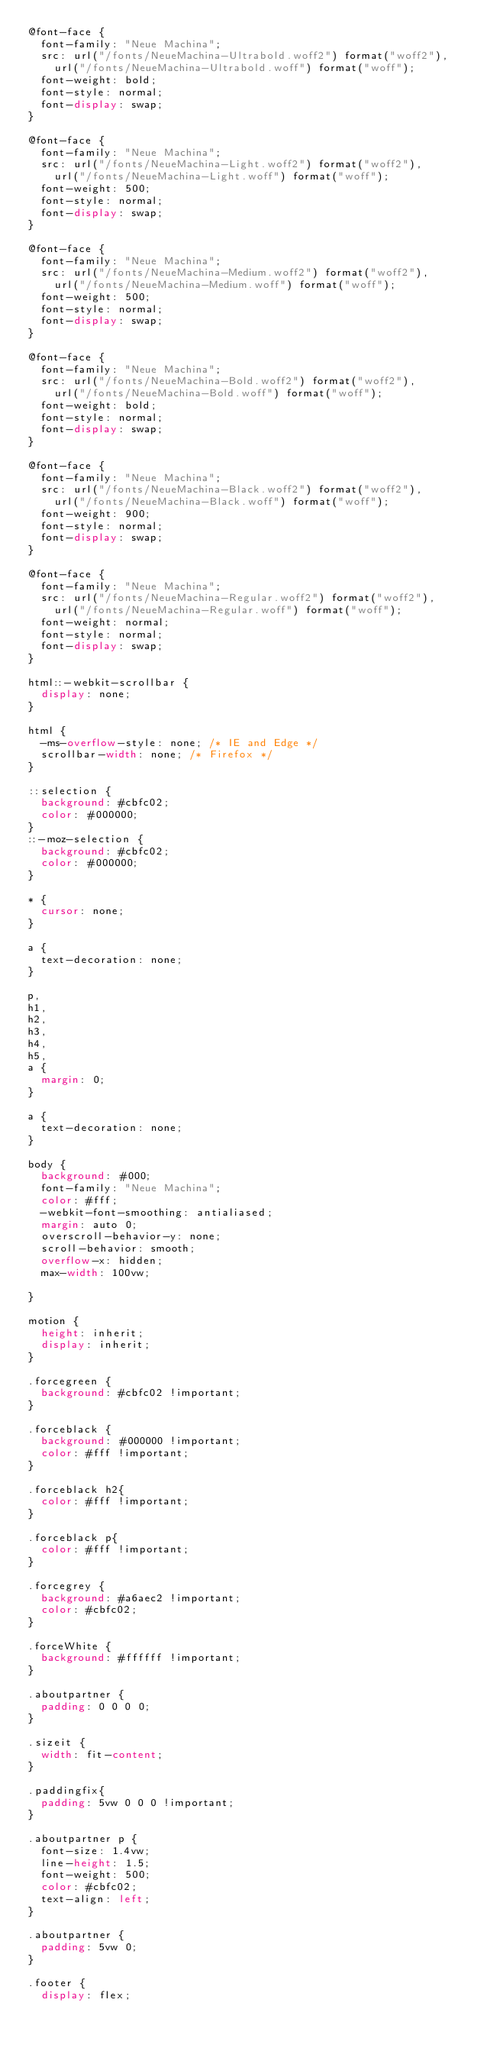Convert code to text. <code><loc_0><loc_0><loc_500><loc_500><_CSS_>@font-face {
  font-family: "Neue Machina";
  src: url("/fonts/NeueMachina-Ultrabold.woff2") format("woff2"),
    url("/fonts/NeueMachina-Ultrabold.woff") format("woff");
  font-weight: bold;
  font-style: normal;
  font-display: swap;
}

@font-face {
  font-family: "Neue Machina";
  src: url("/fonts/NeueMachina-Light.woff2") format("woff2"),
    url("/fonts/NeueMachina-Light.woff") format("woff");
  font-weight: 500;
  font-style: normal;
  font-display: swap;
}

@font-face {
  font-family: "Neue Machina";
  src: url("/fonts/NeueMachina-Medium.woff2") format("woff2"),
    url("/fonts/NeueMachina-Medium.woff") format("woff");
  font-weight: 500;
  font-style: normal;
  font-display: swap;
}

@font-face {
  font-family: "Neue Machina";
  src: url("/fonts/NeueMachina-Bold.woff2") format("woff2"),
    url("/fonts/NeueMachina-Bold.woff") format("woff");
  font-weight: bold;
  font-style: normal;
  font-display: swap;
}

@font-face {
  font-family: "Neue Machina";
  src: url("/fonts/NeueMachina-Black.woff2") format("woff2"),
    url("/fonts/NeueMachina-Black.woff") format("woff");
  font-weight: 900;
  font-style: normal;
  font-display: swap;
}

@font-face {
  font-family: "Neue Machina";
  src: url("/fonts/NeueMachina-Regular.woff2") format("woff2"),
    url("/fonts/NeueMachina-Regular.woff") format("woff");
  font-weight: normal;
  font-style: normal;
  font-display: swap;
}

html::-webkit-scrollbar {
  display: none;
}

html {
  -ms-overflow-style: none; /* IE and Edge */
  scrollbar-width: none; /* Firefox */
}

::selection {
  background: #cbfc02;
  color: #000000;
}
::-moz-selection {
  background: #cbfc02;
  color: #000000;
}

* {
  cursor: none;
}

a {
  text-decoration: none;
}

p,
h1,
h2,
h3,
h4,
h5,
a {
  margin: 0;
}

a {
  text-decoration: none;
}

body {
  background: #000;
  font-family: "Neue Machina";
  color: #fff;
  -webkit-font-smoothing: antialiased;
  margin: auto 0;
  overscroll-behavior-y: none;
  scroll-behavior: smooth;
  overflow-x: hidden;
  max-width: 100vw;
  
}

motion {
  height: inherit;
  display: inherit;
}

.forcegreen {
  background: #cbfc02 !important;
}

.forceblack {
  background: #000000 !important;
  color: #fff !important;
}

.forceblack h2{
  color: #fff !important;
}

.forceblack p{
  color: #fff !important;
}

.forcegrey {
  background: #a6aec2 !important;
  color: #cbfc02;
}

.forceWhite {
  background: #ffffff !important;
}

.aboutpartner {
  padding: 0 0 0 0;
}

.sizeit {
  width: fit-content;
}

.paddingfix{
  padding: 5vw 0 0 0 !important;
}

.aboutpartner p {
  font-size: 1.4vw;
  line-height: 1.5;
  font-weight: 500;
  color: #cbfc02;
  text-align: left;
}

.aboutpartner {
  padding: 5vw 0;
}

.footer {
  display: flex;</code> 